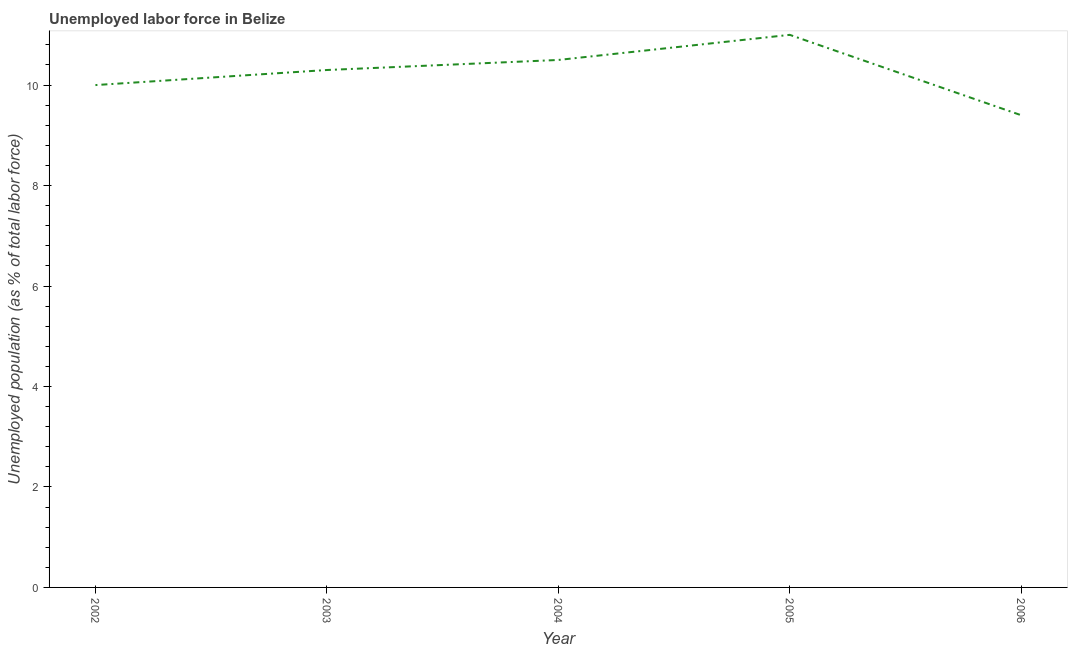What is the total unemployed population in 2002?
Provide a succinct answer. 10. Across all years, what is the minimum total unemployed population?
Offer a very short reply. 9.4. In which year was the total unemployed population maximum?
Your answer should be compact. 2005. In which year was the total unemployed population minimum?
Ensure brevity in your answer.  2006. What is the sum of the total unemployed population?
Keep it short and to the point. 51.2. What is the average total unemployed population per year?
Your answer should be very brief. 10.24. What is the median total unemployed population?
Provide a succinct answer. 10.3. In how many years, is the total unemployed population greater than 0.4 %?
Provide a short and direct response. 5. Do a majority of the years between 2004 and 2002 (inclusive) have total unemployed population greater than 7.2 %?
Keep it short and to the point. No. What is the ratio of the total unemployed population in 2004 to that in 2006?
Offer a very short reply. 1.12. Is the total unemployed population in 2003 less than that in 2005?
Ensure brevity in your answer.  Yes. What is the difference between the highest and the lowest total unemployed population?
Your answer should be very brief. 1.6. Does the total unemployed population monotonically increase over the years?
Provide a succinct answer. No. Are the values on the major ticks of Y-axis written in scientific E-notation?
Your answer should be very brief. No. What is the title of the graph?
Ensure brevity in your answer.  Unemployed labor force in Belize. What is the label or title of the X-axis?
Make the answer very short. Year. What is the label or title of the Y-axis?
Make the answer very short. Unemployed population (as % of total labor force). What is the Unemployed population (as % of total labor force) of 2003?
Your response must be concise. 10.3. What is the Unemployed population (as % of total labor force) in 2004?
Your response must be concise. 10.5. What is the Unemployed population (as % of total labor force) in 2006?
Ensure brevity in your answer.  9.4. What is the difference between the Unemployed population (as % of total labor force) in 2002 and 2005?
Provide a short and direct response. -1. What is the difference between the Unemployed population (as % of total labor force) in 2003 and 2004?
Your answer should be very brief. -0.2. What is the difference between the Unemployed population (as % of total labor force) in 2004 and 2005?
Keep it short and to the point. -0.5. What is the difference between the Unemployed population (as % of total labor force) in 2005 and 2006?
Your response must be concise. 1.6. What is the ratio of the Unemployed population (as % of total labor force) in 2002 to that in 2005?
Offer a very short reply. 0.91. What is the ratio of the Unemployed population (as % of total labor force) in 2002 to that in 2006?
Your response must be concise. 1.06. What is the ratio of the Unemployed population (as % of total labor force) in 2003 to that in 2005?
Your answer should be compact. 0.94. What is the ratio of the Unemployed population (as % of total labor force) in 2003 to that in 2006?
Ensure brevity in your answer.  1.1. What is the ratio of the Unemployed population (as % of total labor force) in 2004 to that in 2005?
Ensure brevity in your answer.  0.95. What is the ratio of the Unemployed population (as % of total labor force) in 2004 to that in 2006?
Offer a terse response. 1.12. What is the ratio of the Unemployed population (as % of total labor force) in 2005 to that in 2006?
Make the answer very short. 1.17. 